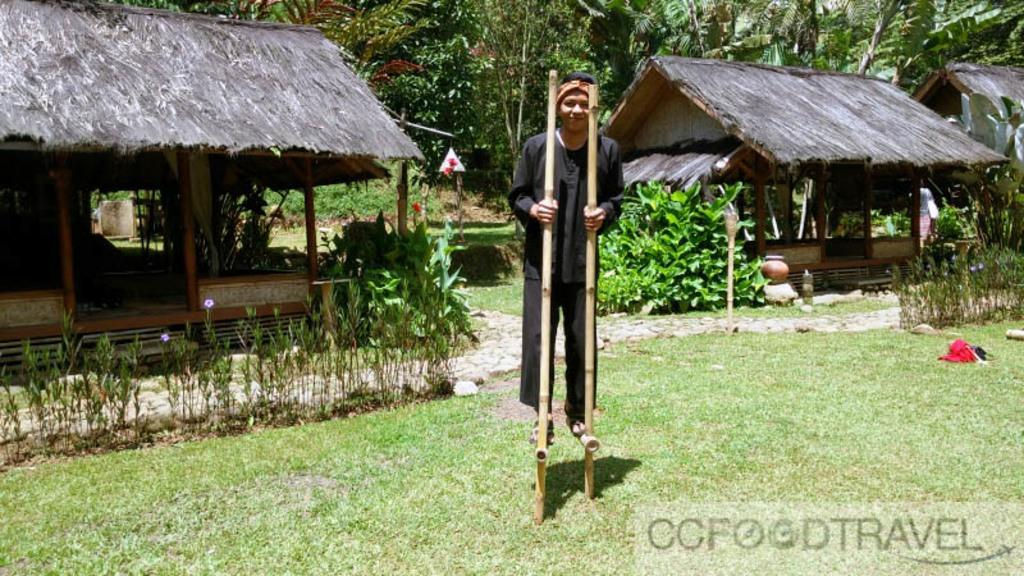What is the person in the image doing? The person is standing on sticks above the ground. What can be seen in the background of the image? There are thatched houses, trees, pots, plants, and bushes visible in the background. How many types of structures are present in the background? There are two types of structures in the background: thatched houses and pots. What word is the person saying in the image? There is no indication of the person speaking or saying any word in the image. How many men are visible in the image? There is only one person visible in the image, and it is not specified whether they are male or female. 